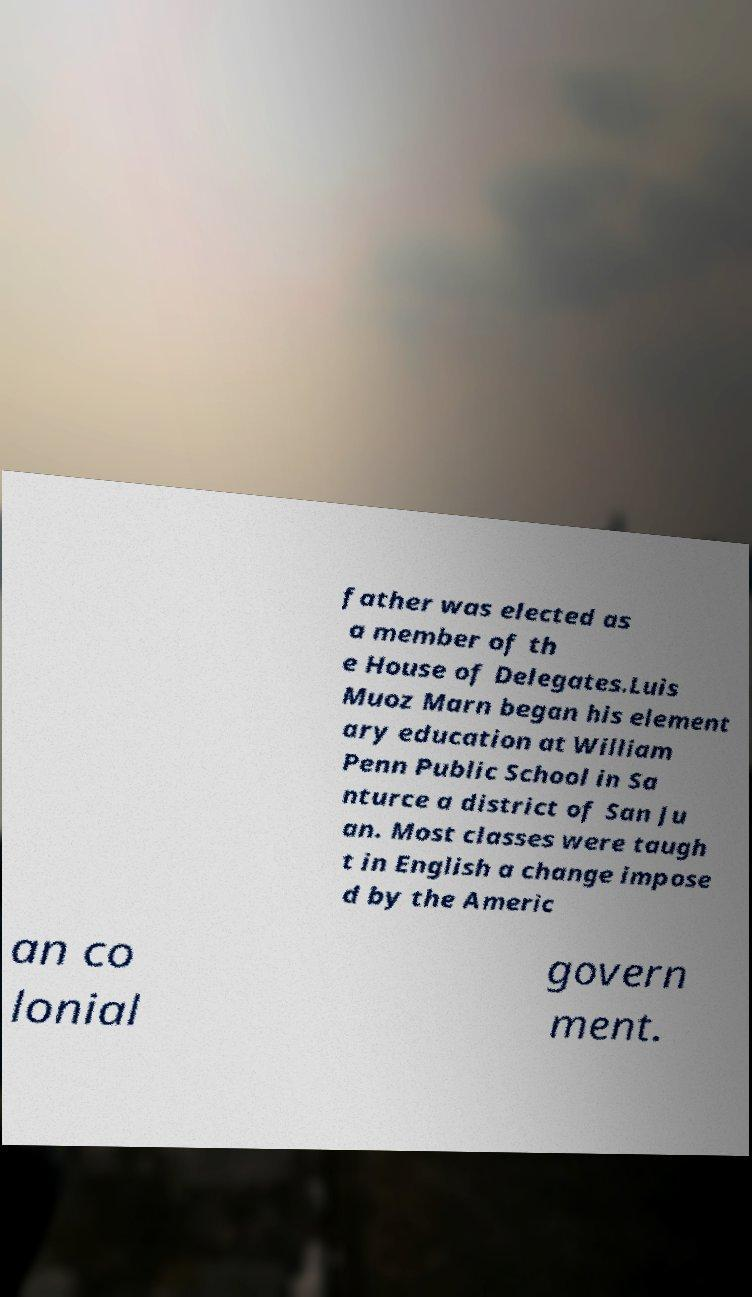For documentation purposes, I need the text within this image transcribed. Could you provide that? father was elected as a member of th e House of Delegates.Luis Muoz Marn began his element ary education at William Penn Public School in Sa nturce a district of San Ju an. Most classes were taugh t in English a change impose d by the Americ an co lonial govern ment. 